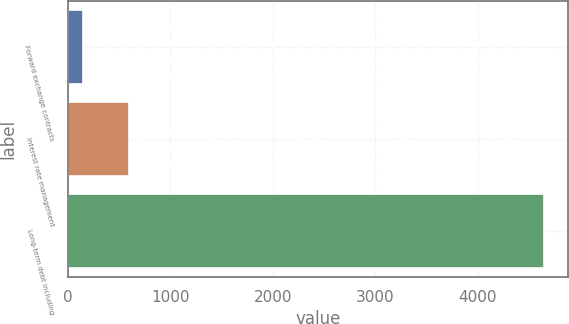<chart> <loc_0><loc_0><loc_500><loc_500><bar_chart><fcel>Forward exchange contracts<fcel>Interest rate management<fcel>Long-term debt including<nl><fcel>147.1<fcel>596.96<fcel>4645.7<nl></chart> 